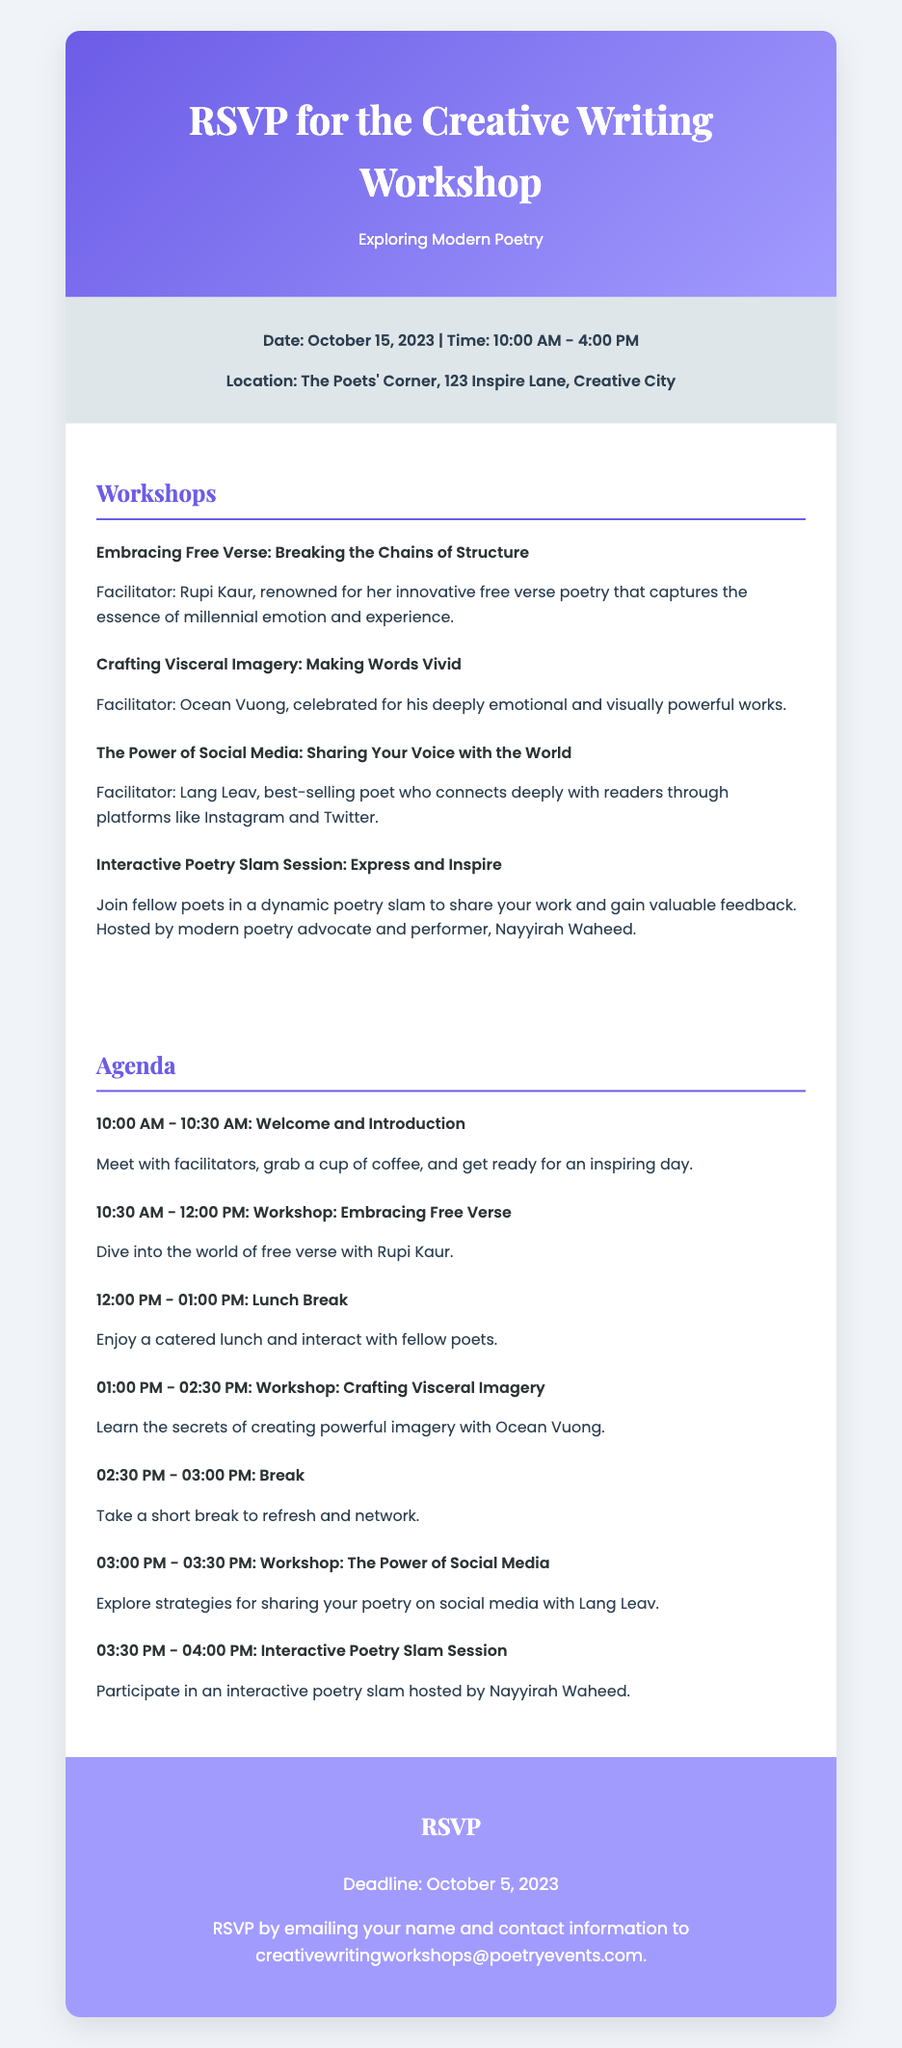What is the date of the workshop? The date of the workshop is mentioned in the event details section of the document as October 15, 2023.
Answer: October 15, 2023 Who is the facilitator for the workshop on free verse? The facilitator for the workshop titled "Embracing Free Verse: Breaking the Chains of Structure" is listed in the document as Rupi Kaur.
Answer: Rupi Kaur What time does the lunch break start? The lunch break time is indicated within the agenda section of the document as 12:00 PM.
Answer: 12:00 PM How many workshops are there in total? The total number of workshops can be counted from the workshops section, which lists four individual workshops.
Answer: Four What is the deadline to RSVP? The RSVP deadline is specified in the RSVP section of the document as October 5, 2023.
Answer: October 5, 2023 Which workshop focuses on social media? The document states that "The Power of Social Media: Sharing Your Voice with the World" is the workshop focusing on social media.
Answer: The Power of Social Media: Sharing Your Voice with the World How long is each workshop scheduled? The duration of each workshop can be deduced from the agenda, where the workshops usually run for about 1.5 hours or 30 minutes each.
Answer: 1.5 hours Who is hosting the interactive poetry slam session? The document lists Nayyirah Waheed as the host for the interactive poetry slam session.
Answer: Nayyirah Waheed 